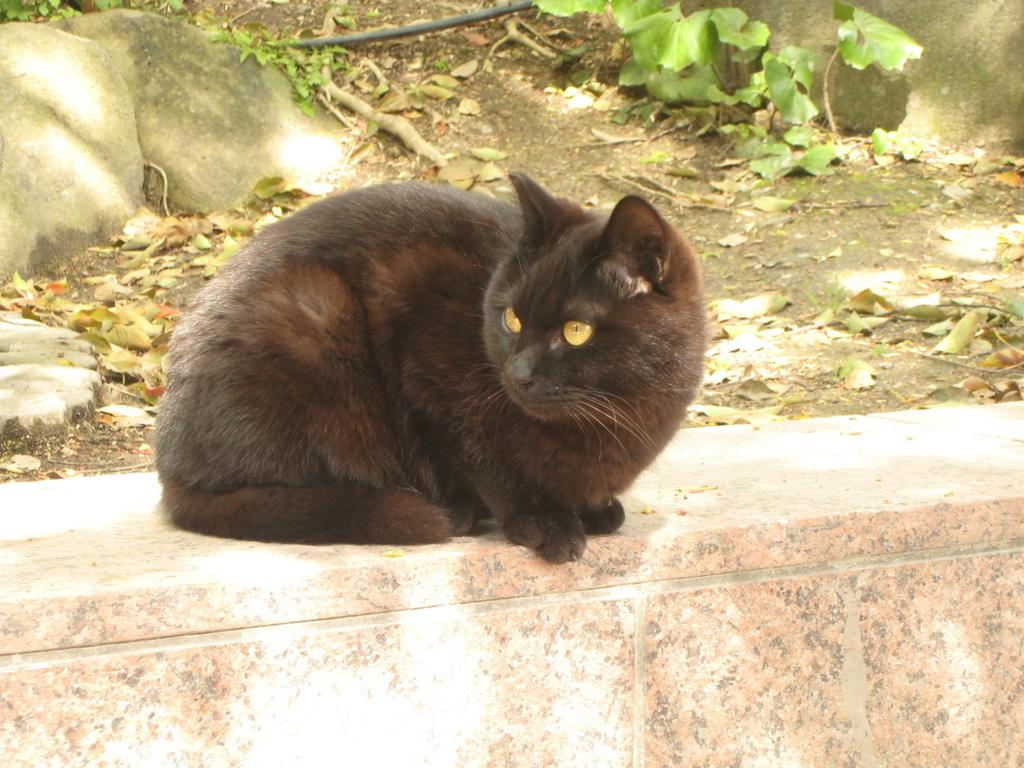What type of animal can be seen on the wall in the image? There is a black color cat visible on the wall at the bottom. What natural elements are present in the image? Leaves and stones are visible in the image. What type of needle is being used to sew the cat's fur in the image? There is no needle or sewing activity present in the image; it features a cat on the wall and leaves and stones. 